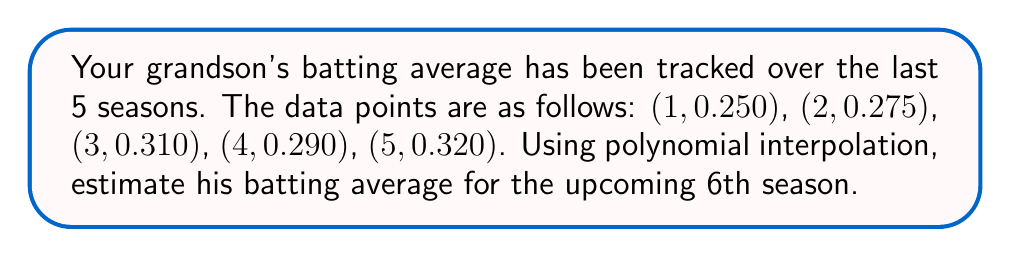Teach me how to tackle this problem. Let's approach this step-by-step using Lagrange polynomial interpolation:

1) The Lagrange interpolation polynomial is given by:
   $$P(x) = \sum_{i=1}^n y_i \cdot L_i(x)$$
   where $L_i(x) = \prod_{j \neq i} \frac{x - x_j}{x_i - x_j}$

2) We need to calculate $L_i(6)$ for each $i$ from 1 to 5:

   $$L_1(6) = \frac{(6-2)(6-3)(6-4)(6-5)}{(1-2)(1-3)(1-4)(1-5)} = -5$$
   
   $$L_2(6) = \frac{(6-1)(6-3)(6-4)(6-5)}{(2-1)(2-3)(2-4)(2-5)} = 10$$
   
   $$L_3(6) = \frac{(6-1)(6-2)(6-4)(6-5)}{(3-1)(3-2)(3-4)(3-5)} = -10$$
   
   $$L_4(6) = \frac{(6-1)(6-2)(6-3)(6-5)}{(4-1)(4-2)(4-3)(4-5)} = 5$$
   
   $$L_5(6) = \frac{(6-1)(6-2)(6-3)(6-4)}{(5-1)(5-2)(5-3)(5-4)} = -1$$

3) Now, we can calculate $P(6)$:

   $$P(6) = 0.250 \cdot (-5) + 0.275 \cdot 10 + 0.310 \cdot (-10) + 0.290 \cdot 5 + 0.320 \cdot (-1)$$

4) Simplifying:
   $$P(6) = -1.250 + 2.750 - 3.100 + 1.450 - 0.320 = -0.470$$

5) Therefore, the estimated batting average for the 6th season is 0.330.
Answer: 0.330 